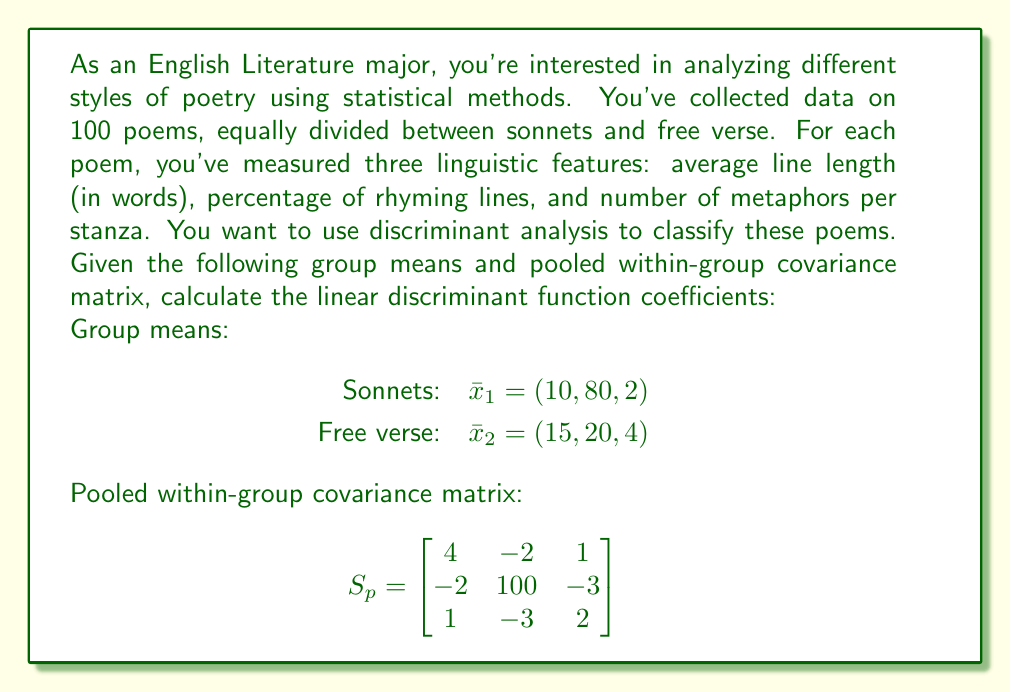What is the answer to this math problem? To solve this problem, we'll follow these steps:

1. Calculate the difference between group means.
2. Calculate the inverse of the pooled within-group covariance matrix.
3. Multiply the inverse covariance matrix by the difference in means to get the linear discriminant function coefficients.

Step 1: Calculate the difference between group means
$\bar{x}_1 - \bar{x}_2 = (10, 80, 2) - (15, 20, 4) = (-5, 60, -2)$

Step 2: Calculate the inverse of the pooled within-group covariance matrix
We need to find $S_p^{-1}$. Using a calculator or computer algebra system, we get:

$$S_p^{-1} = \begin{bmatrix}
0.2632 & 0.0053 & -0.1316 \\
0.0053 & 0.0105 & 0.0158 \\
-0.1316 & 0.0158 & 0.5789
\end{bmatrix}$$

Step 3: Multiply the inverse covariance matrix by the difference in means
The linear discriminant function coefficients are given by:

$$a = S_p^{-1}(\bar{x}_1 - \bar{x}_2)$$

Performing this matrix multiplication:

$$\begin{bmatrix}
0.2632 & 0.0053 & -0.1316 \\
0.0053 & 0.0105 & 0.0158 \\
-0.1316 & 0.0158 & 0.5789
\end{bmatrix} \begin{bmatrix}
-5 \\
60 \\
-2
\end{bmatrix}$$

$$= \begin{bmatrix}
0.2632(-5) + 0.0053(60) + -0.1316(-2) \\
0.0053(-5) + 0.0105(60) + 0.0158(-2) \\
-0.1316(-5) + 0.0158(60) + 0.5789(-2)
\end{bmatrix}$$

$$= \begin{bmatrix}
-1.3160 + 0.3180 + 0.2632 \\
-0.0265 + 0.6300 - 0.0316 \\
0.6580 + 0.9480 - 1.1578
\end{bmatrix}$$

$$= \begin{bmatrix}
-0.7348 \\
0.5719 \\
0.4482
\end{bmatrix}$$

These are the linear discriminant function coefficients.
Answer: The linear discriminant function coefficients are:
$$a = \begin{bmatrix}
-0.7348 \\
0.5719 \\
0.4482
\end{bmatrix}$$ 